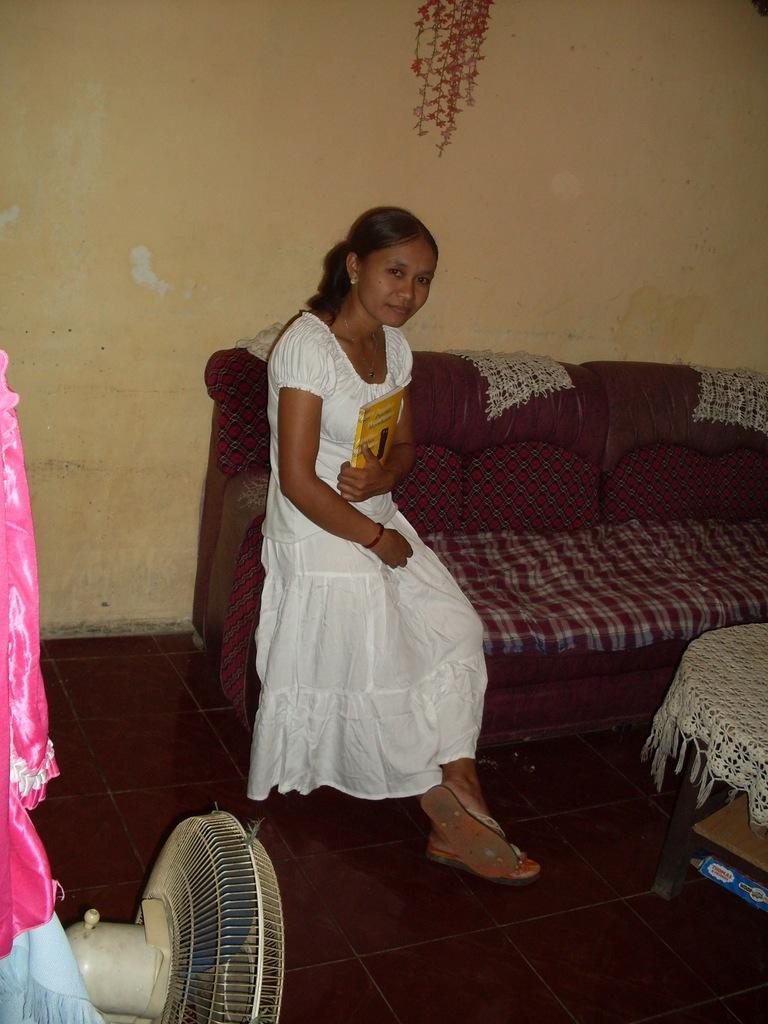Who is present in the image? There is a woman in the image. What is the woman doing in the image? The woman is sitting on a sofa and holding a book. What can be seen in the image besides the woman? There is a fan, a table, and a wall in the background of the image. Where is the kitten playing in the image? There is no kitten present in the image. What type of beetle can be seen crawling on the wall in the image? There are no beetles visible in the image; only the woman, the sofa, the book, the fan, the table, and the wall are present. 